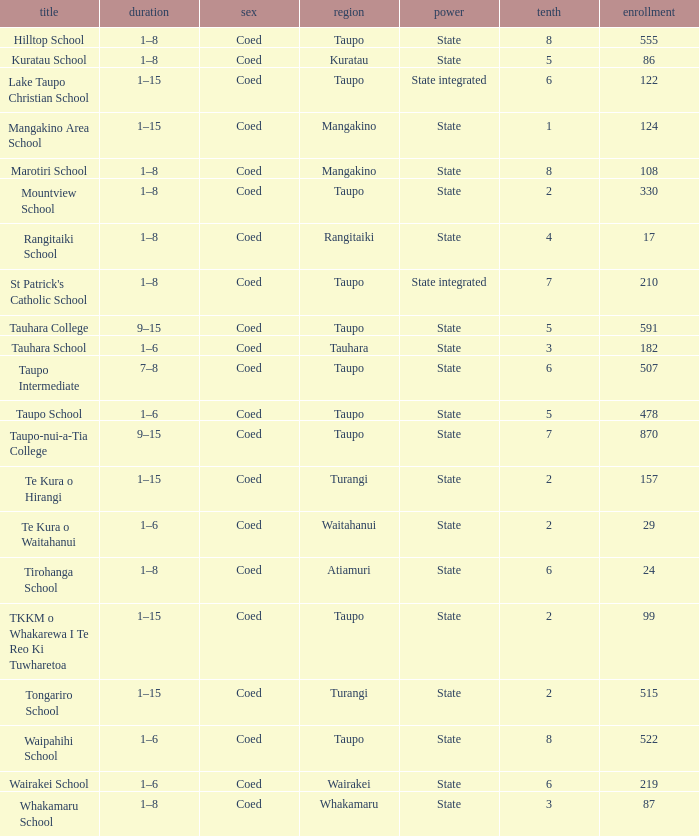Where is the school with state authority that has a roll of more than 157 students? Taupo, Taupo, Taupo, Tauhara, Taupo, Taupo, Taupo, Turangi, Taupo, Wairakei. 